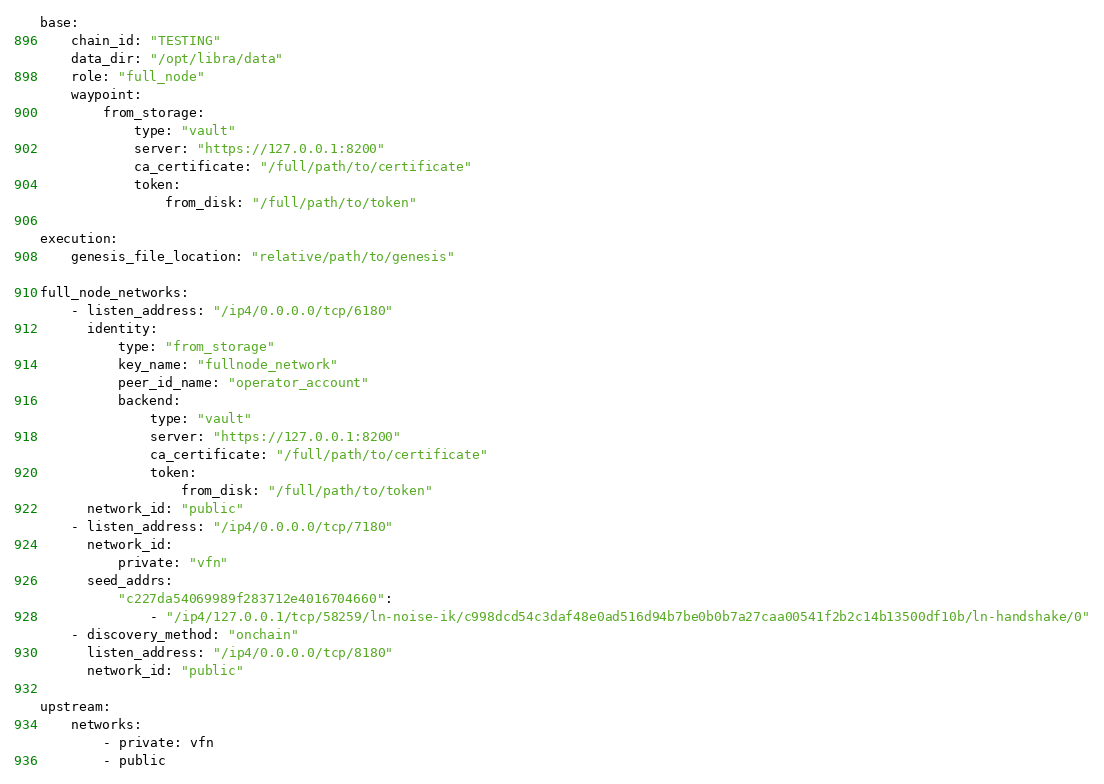Convert code to text. <code><loc_0><loc_0><loc_500><loc_500><_YAML_>base:
    chain_id: "TESTING"
    data_dir: "/opt/libra/data"
    role: "full_node"
    waypoint:
        from_storage:
            type: "vault"
            server: "https://127.0.0.1:8200"
            ca_certificate: "/full/path/to/certificate"
            token:
                from_disk: "/full/path/to/token"

execution:
    genesis_file_location: "relative/path/to/genesis"

full_node_networks:
    - listen_address: "/ip4/0.0.0.0/tcp/6180"
      identity:
          type: "from_storage"
          key_name: "fullnode_network"
          peer_id_name: "operator_account"
          backend:
              type: "vault"
              server: "https://127.0.0.1:8200"
              ca_certificate: "/full/path/to/certificate"
              token:
                  from_disk: "/full/path/to/token"
      network_id: "public"
    - listen_address: "/ip4/0.0.0.0/tcp/7180"
      network_id:
          private: "vfn"
      seed_addrs:
          "c227da54069989f283712e4016704660":
              - "/ip4/127.0.0.1/tcp/58259/ln-noise-ik/c998dcd54c3daf48e0ad516d94b7be0b0b7a27caa00541f2b2c14b13500df10b/ln-handshake/0"
    - discovery_method: "onchain"
      listen_address: "/ip4/0.0.0.0/tcp/8180"
      network_id: "public"

upstream:
    networks:
        - private: vfn
        - public
</code> 